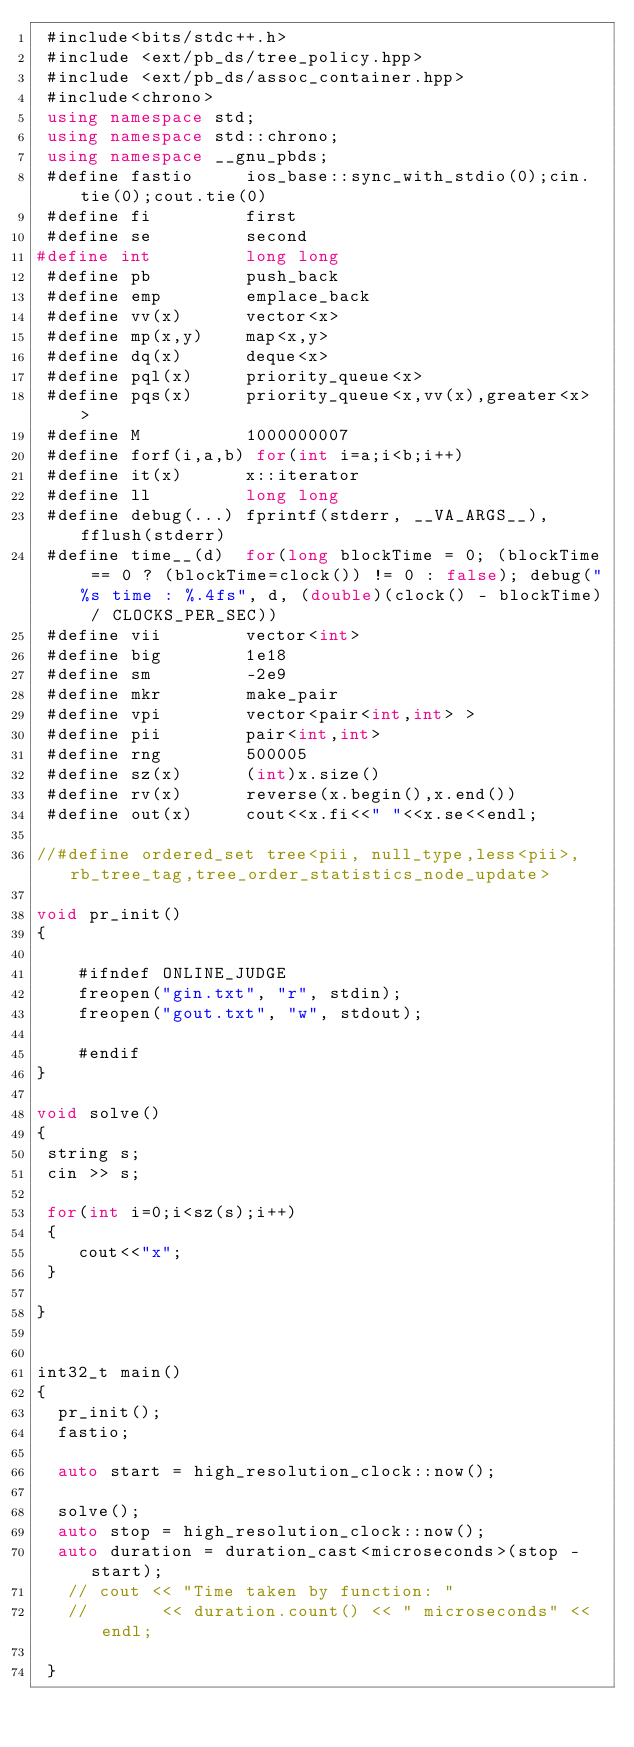<code> <loc_0><loc_0><loc_500><loc_500><_C++_> #include<bits/stdc++.h>
 #include <ext/pb_ds/tree_policy.hpp>
 #include <ext/pb_ds/assoc_container.hpp>
 #include<chrono>
 using namespace std;
 using namespace std::chrono;      
 using namespace __gnu_pbds; 
 #define fastio     ios_base::sync_with_stdio(0);cin.tie(0);cout.tie(0)
 #define fi         first
 #define se         second
#define int         long long 
 #define pb         push_back
 #define emp        emplace_back
 #define vv(x)      vector<x>
 #define mp(x,y)    map<x,y>
 #define dq(x)      deque<x>
 #define pql(x)     priority_queue<x>
 #define pqs(x)     priority_queue<x,vv(x),greater<x> >
 #define M          1000000007
 #define forf(i,a,b) for(int i=a;i<b;i++)
 #define it(x)      x::iterator
 #define ll         long long 
 #define debug(...) fprintf(stderr, __VA_ARGS__), fflush(stderr)
 #define time__(d)  for(long blockTime = 0; (blockTime == 0 ? (blockTime=clock()) != 0 : false); debug("%s time : %.4fs", d, (double)(clock() - blockTime) / CLOCKS_PER_SEC))
 #define vii        vector<int>
 #define big        1e18
 #define sm         -2e9
 #define mkr        make_pair
 #define vpi        vector<pair<int,int> >
 #define pii        pair<int,int>
 #define rng        500005
 #define sz(x)      (int)x.size()
 #define rv(x)      reverse(x.begin(),x.end())
 #define out(x)     cout<<x.fi<<" "<<x.se<<endl;

//#define ordered_set tree<pii, null_type,less<pii>, rb_tree_tag,tree_order_statistics_node_update> 
  
void pr_init()
{
   
    #ifndef ONLINE_JUDGE
    freopen("gin.txt", "r", stdin);
    freopen("gout.txt", "w", stdout);
   
    #endif
}

void solve()
{
 string s;
 cin >> s;

 for(int i=0;i<sz(s);i++)
 {
    cout<<"x";
 }

}


int32_t main()
{
  pr_init();
  fastio;
  
  auto start = high_resolution_clock::now(); 
 
  solve();
  auto stop = high_resolution_clock::now();
  auto duration = duration_cast<microseconds>(stop - start); 
   // cout << "Time taken by function: "
   //       << duration.count() << " microseconds" << endl; 

 }
      
      </code> 